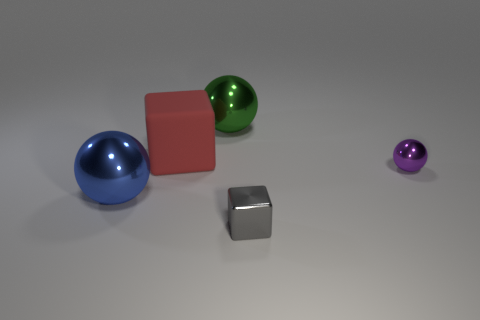Are there any other things that have the same size as the green sphere?
Provide a succinct answer. Yes. What number of tiny things are either green shiny cylinders or blue balls?
Your response must be concise. 0. Are there fewer spheres than tiny brown matte cylinders?
Ensure brevity in your answer.  No. What is the color of the other metallic object that is the same shape as the red thing?
Keep it short and to the point. Gray. Is there anything else that has the same shape as the large red thing?
Ensure brevity in your answer.  Yes. Is the number of purple metal objects greater than the number of large metal spheres?
Offer a very short reply. No. How many other things are made of the same material as the large red thing?
Provide a succinct answer. 0. There is a object in front of the large ball that is in front of the ball that is on the right side of the gray cube; what is its shape?
Ensure brevity in your answer.  Cube. Is the number of large cubes on the left side of the small gray shiny block less than the number of big cubes to the right of the green thing?
Ensure brevity in your answer.  No. Are there any small metal balls of the same color as the big rubber block?
Offer a very short reply. No. 